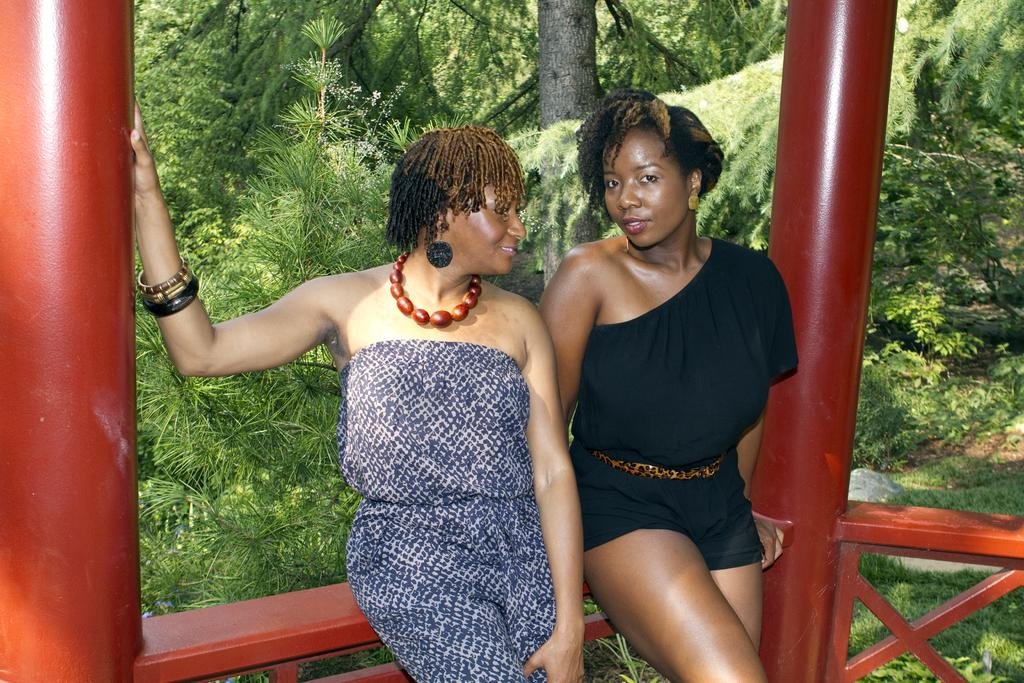What are the women in the image doing? The two women are sitting on a fence in the image. What can be seen in the foreground of the image? There are poles visible in the image. What is visible on the backside of the image? The bark of a tree, plants, and a group of trees are present on the backside of the image. How many kittens are sitting on the fence with the women in the image? There are no kittens present in the image; only the two women are sitting on the fence. 